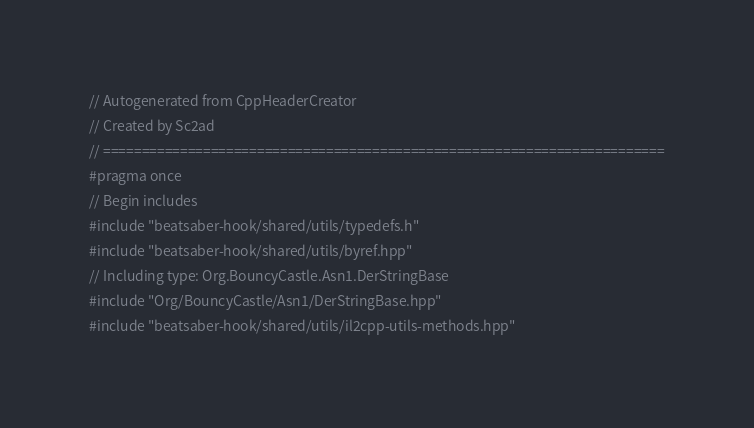Convert code to text. <code><loc_0><loc_0><loc_500><loc_500><_C++_>// Autogenerated from CppHeaderCreator
// Created by Sc2ad
// =========================================================================
#pragma once
// Begin includes
#include "beatsaber-hook/shared/utils/typedefs.h"
#include "beatsaber-hook/shared/utils/byref.hpp"
// Including type: Org.BouncyCastle.Asn1.DerStringBase
#include "Org/BouncyCastle/Asn1/DerStringBase.hpp"
#include "beatsaber-hook/shared/utils/il2cpp-utils-methods.hpp"</code> 